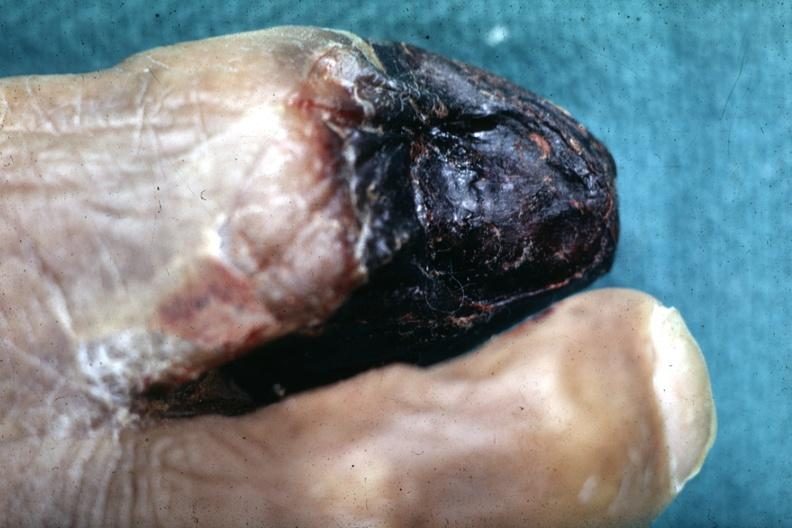what are present?
Answer the question using a single word or phrase. Extremities 